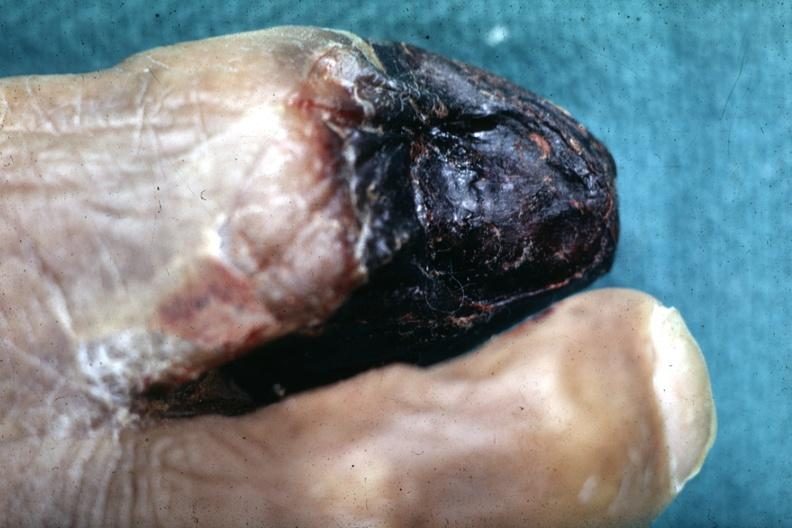what are present?
Answer the question using a single word or phrase. Extremities 